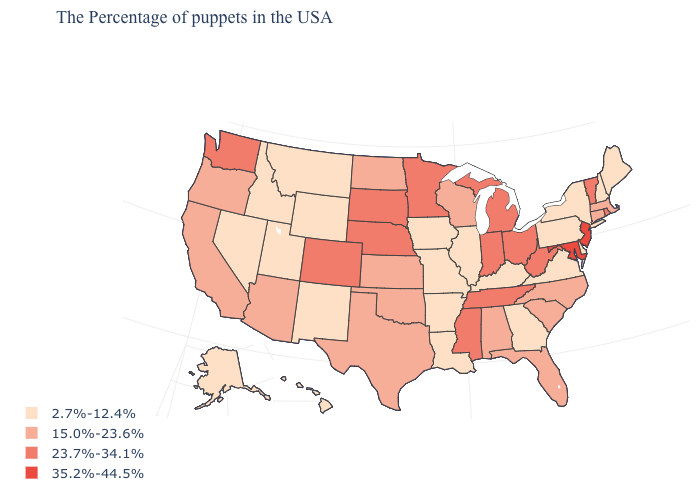Among the states that border Indiana , does Ohio have the lowest value?
Short answer required. No. Name the states that have a value in the range 2.7%-12.4%?
Quick response, please. Maine, New Hampshire, New York, Delaware, Pennsylvania, Virginia, Georgia, Kentucky, Illinois, Louisiana, Missouri, Arkansas, Iowa, Wyoming, New Mexico, Utah, Montana, Idaho, Nevada, Alaska, Hawaii. Does Illinois have a lower value than Connecticut?
Keep it brief. Yes. Is the legend a continuous bar?
Write a very short answer. No. What is the lowest value in the USA?
Concise answer only. 2.7%-12.4%. What is the lowest value in states that border North Carolina?
Quick response, please. 2.7%-12.4%. Name the states that have a value in the range 35.2%-44.5%?
Give a very brief answer. New Jersey, Maryland. What is the lowest value in the USA?
Concise answer only. 2.7%-12.4%. Name the states that have a value in the range 23.7%-34.1%?
Answer briefly. Rhode Island, Vermont, West Virginia, Ohio, Michigan, Indiana, Tennessee, Mississippi, Minnesota, Nebraska, South Dakota, Colorado, Washington. Among the states that border Montana , does Wyoming have the highest value?
Concise answer only. No. Among the states that border New York , which have the lowest value?
Give a very brief answer. Pennsylvania. What is the lowest value in the USA?
Concise answer only. 2.7%-12.4%. Which states have the highest value in the USA?
Give a very brief answer. New Jersey, Maryland. What is the value of Pennsylvania?
Be succinct. 2.7%-12.4%. What is the value of Wyoming?
Keep it brief. 2.7%-12.4%. 